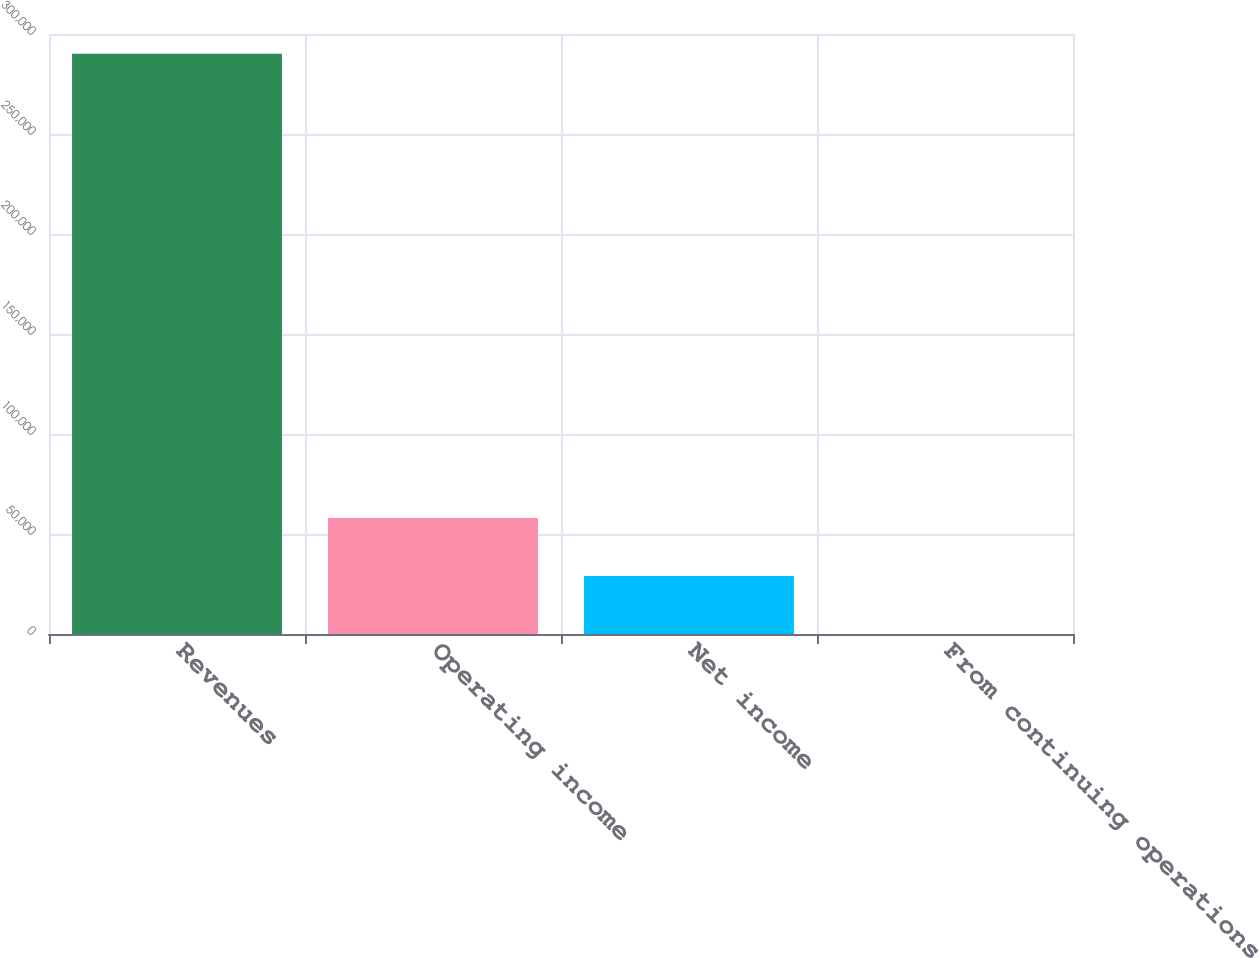Convert chart. <chart><loc_0><loc_0><loc_500><loc_500><bar_chart><fcel>Revenues<fcel>Operating income<fcel>Net income<fcel>From continuing operations<nl><fcel>290099<fcel>58019.9<fcel>29010<fcel>0.15<nl></chart> 